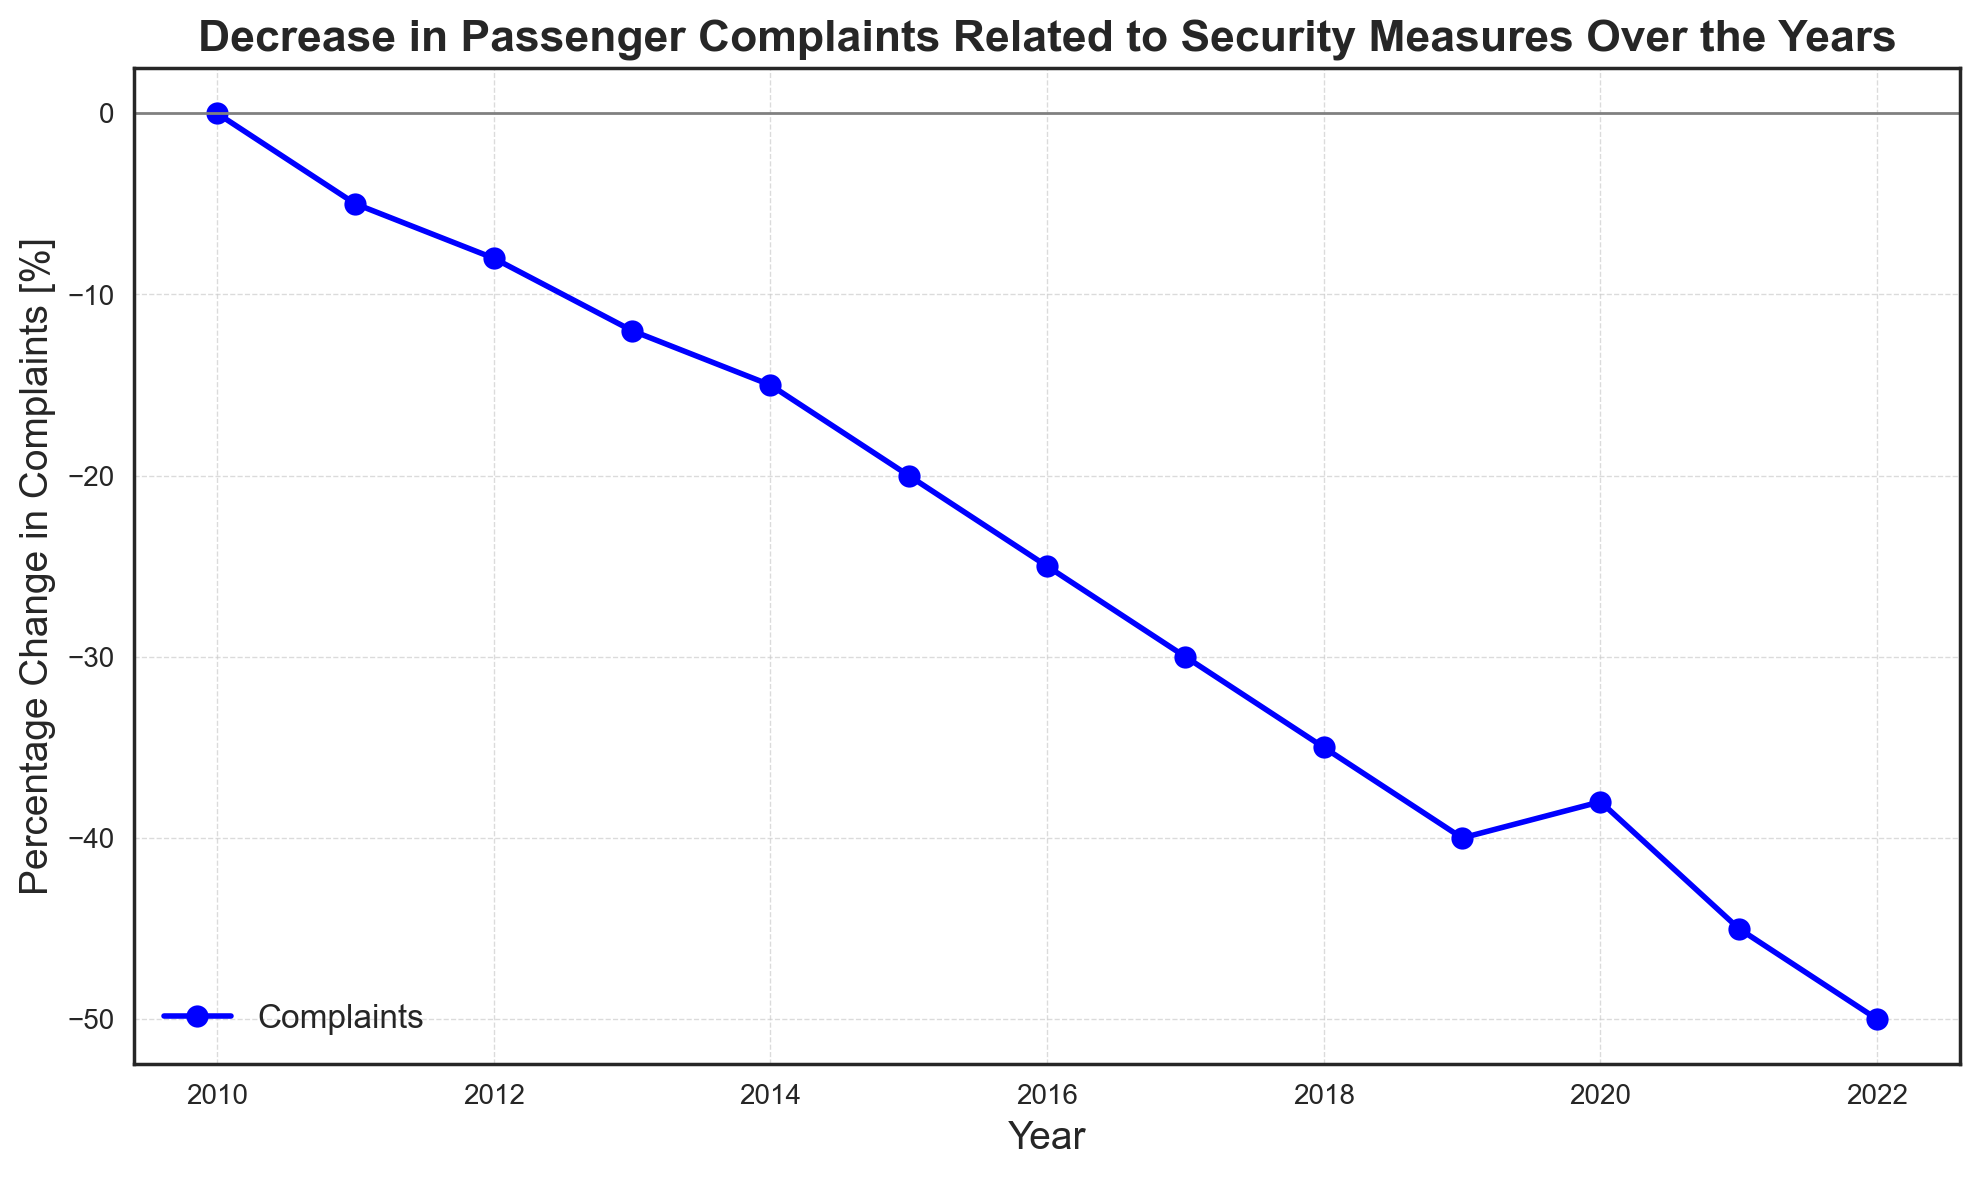What is the percentage change in complaints in 2017? In 2017, the percentage change in complaints can be directly read from the plot.
Answer: -30 How many years showed a decreasing trend in passenger complaints compared to the previous year? From 2010 to 2022, each year shows a further decrease in complaints, indicating a consistently decreasing trend. Thus, excluding 2010, there are 12 decreasing years.
Answer: 12 Which year experienced the largest drop in the percentage of complaints from the previous year? Comparing the differences year-on-year, the year 2019 going to 2020 shows an increase (i.e., -40 to -38 is a small increase in complaints). The largest drop can be seen when comparing 2021 to 2022, a drop from -45% to -50%, a difference of 5%.
Answer: 2021 to 2022 What is the average rate of change in complaints per year between 2010 and 2022? The total decrease is from 0% in 2010 to -50% in 2022, a total difference of 50%. Over 12 years (2022 - 2010), the average rate of change is 50% / 12 years = 4.17% annually.
Answer: -4.17% per year Compare the percentage change in complaints for 2015 and 2018. Which year had a greater decrease? In 2015 the percentage is -20%, and in 2018 it is -35%. Since -35% represents a greater decrease compared to -20%, the greater decrease is in 2018.
Answer: 2018 What trend can be observed between 2016 and 2020? From 2016 to 2020, the percentage change in complaints continues to decrease each year: -25% in 2016, -30% in 2017, -35% in 2018, -40% in 2019, and then slightly up to -38% in 2020. Overall, there is a decreasing trend with a slight increase in 2020.
Answer: Decreasing trend with slight increase in 2020 By how much did the percentage change in complaints decrease from 2011 to 2012? The percentage change in 2011 is -5% and in 2012 is -8%. The decrease is thus 8 - 5 = 3%.
Answer: 3% How many years showed a decrement greater than 5% compared to the previous year? Reviewing each decrement between consecutive years for those greater than 5%: 2014 (-3%), 2015 (-5%), 2016 (-5%), 2017 (-5%), 2020 (+2%), 2022 (-5%) do not meet the criteria. The rest of the years show decrements greater than 5%. Total years are 7 (2011-2012, 2012-2013, 2013-2014, 2015-2016, 2017-2018, 2018-2019, 2021-2022).
Answer: 7 When did the percentage change in complaints first hit -20%? According to the plot, the percentage change hits -20% in 2015.
Answer: 2015 